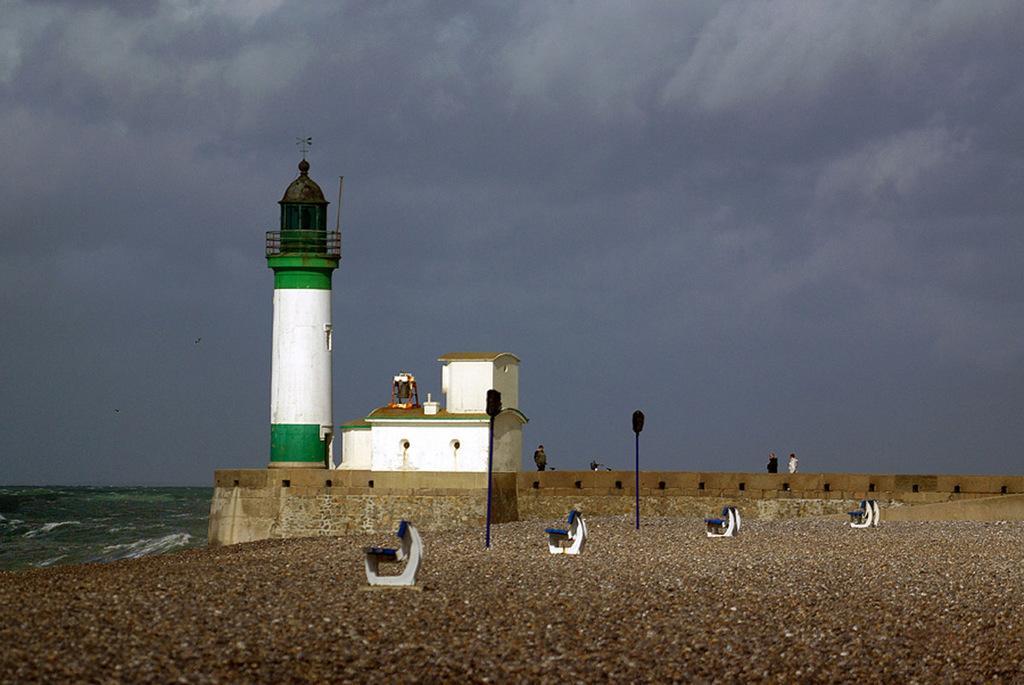Could you give a brief overview of what you see in this image? In this image we can see there is a lighthouse on the ground. And there are people standing beside the lighthouse. And there are benches, poles and wall. In front of the lighthouse there is water and the sky. 